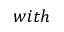<formula> <loc_0><loc_0><loc_500><loc_500>w i t h</formula> 